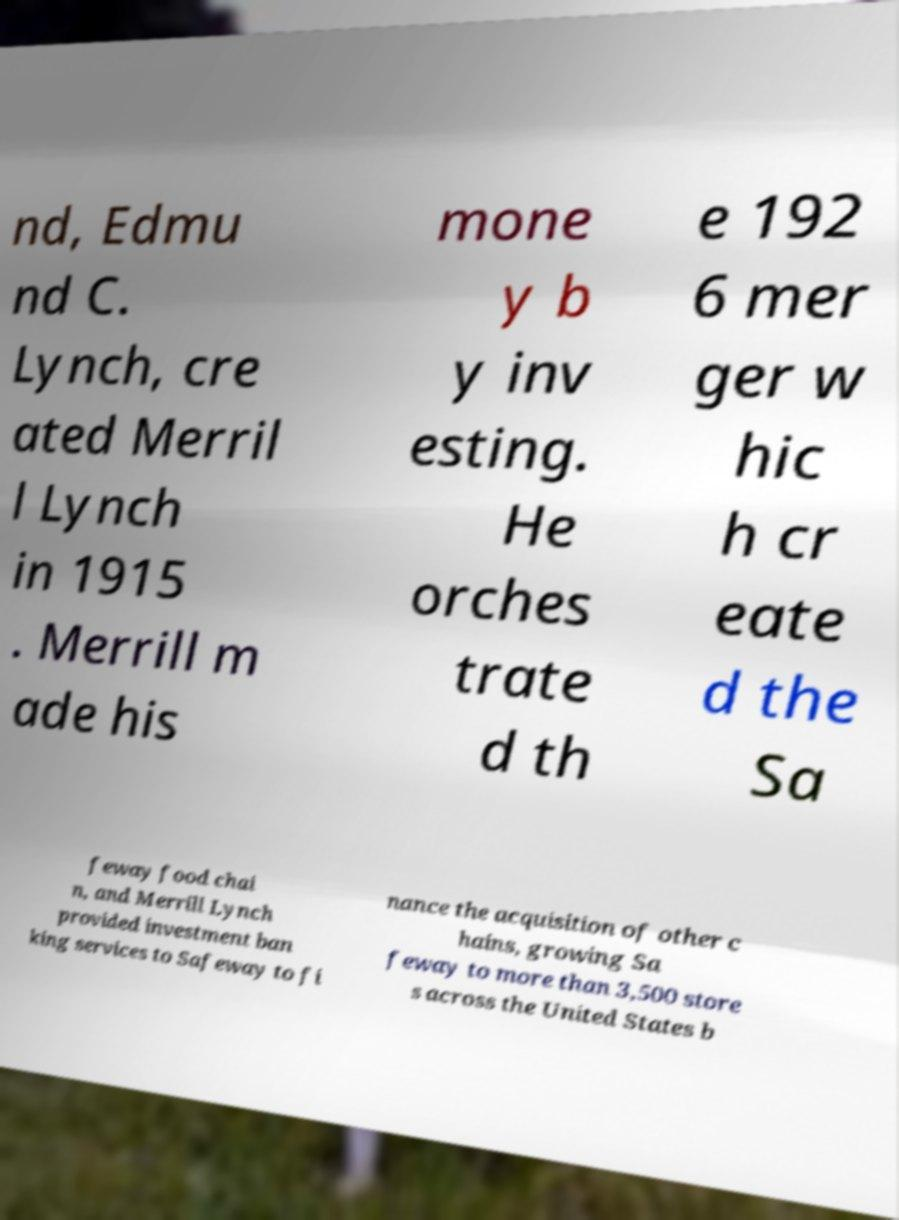What messages or text are displayed in this image? I need them in a readable, typed format. nd, Edmu nd C. Lynch, cre ated Merril l Lynch in 1915 . Merrill m ade his mone y b y inv esting. He orches trate d th e 192 6 mer ger w hic h cr eate d the Sa feway food chai n, and Merrill Lynch provided investment ban king services to Safeway to fi nance the acquisition of other c hains, growing Sa feway to more than 3,500 store s across the United States b 